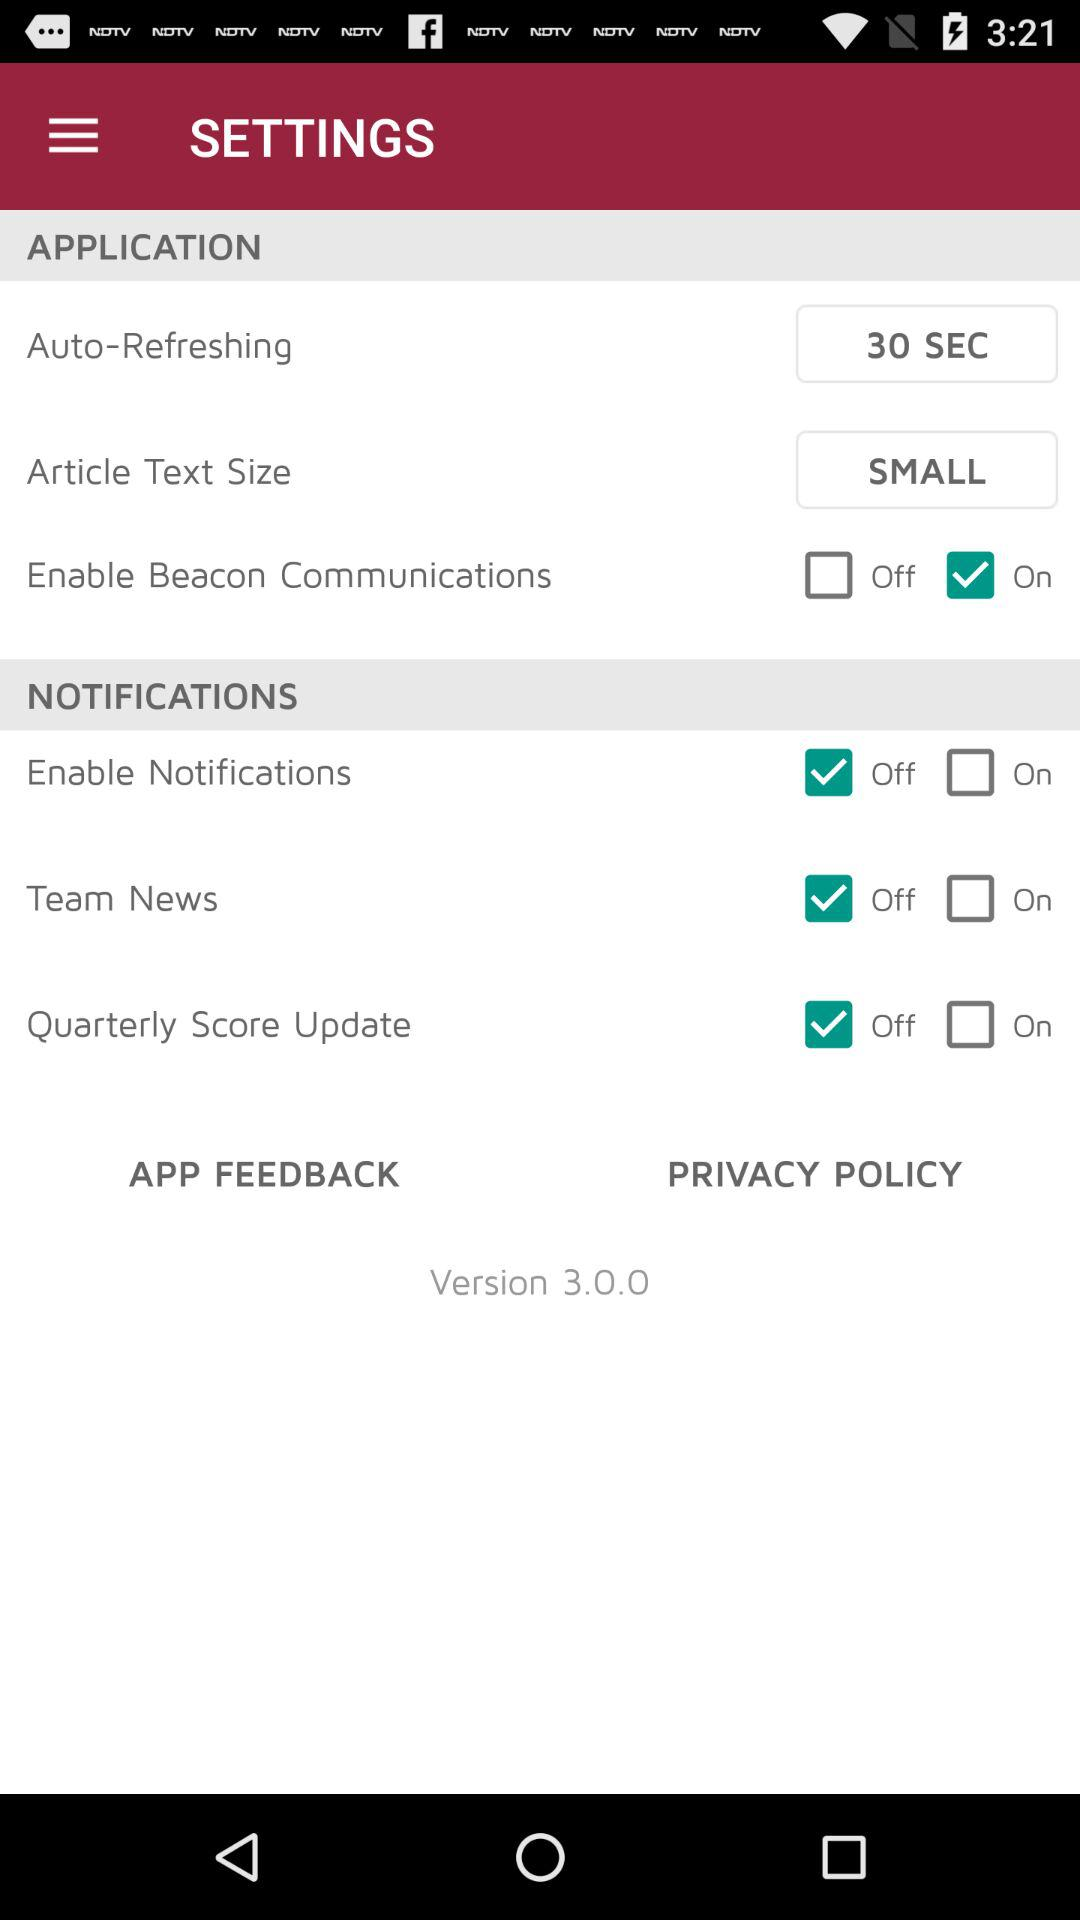Which option has "on" status? The option that has "on" status is "Enable Beacon Communications". 